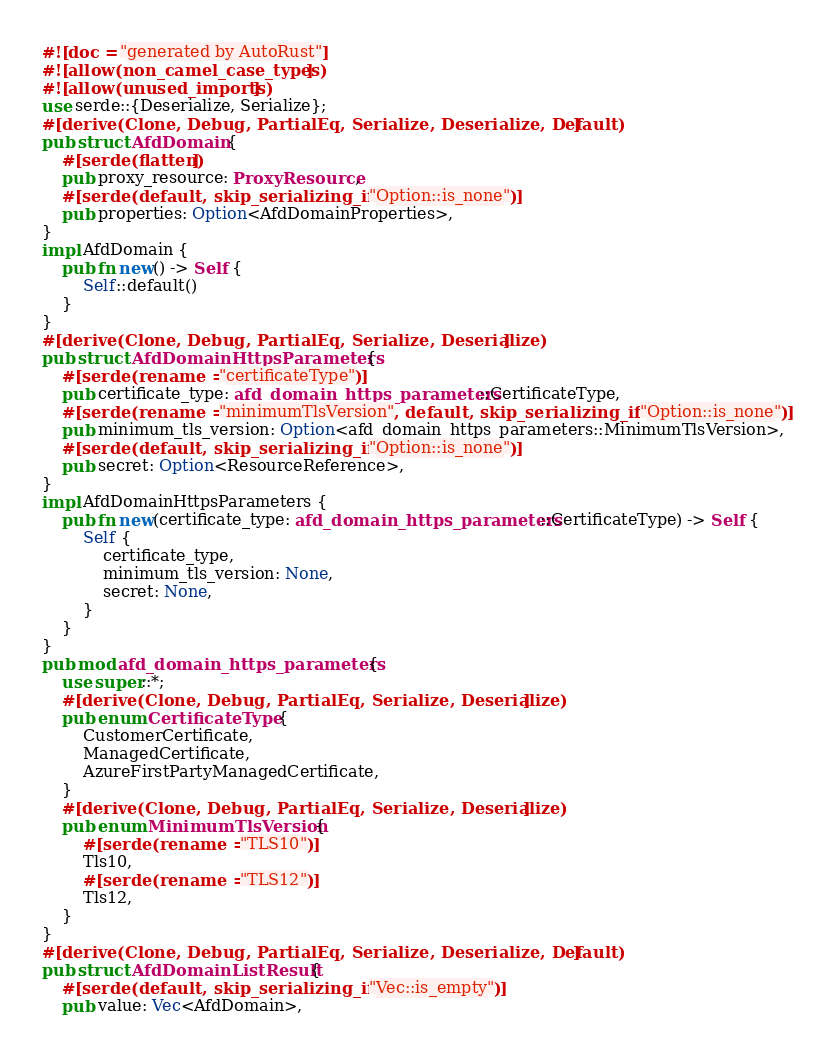<code> <loc_0><loc_0><loc_500><loc_500><_Rust_>#![doc = "generated by AutoRust"]
#![allow(non_camel_case_types)]
#![allow(unused_imports)]
use serde::{Deserialize, Serialize};
#[derive(Clone, Debug, PartialEq, Serialize, Deserialize, Default)]
pub struct AfdDomain {
    #[serde(flatten)]
    pub proxy_resource: ProxyResource,
    #[serde(default, skip_serializing_if = "Option::is_none")]
    pub properties: Option<AfdDomainProperties>,
}
impl AfdDomain {
    pub fn new() -> Self {
        Self::default()
    }
}
#[derive(Clone, Debug, PartialEq, Serialize, Deserialize)]
pub struct AfdDomainHttpsParameters {
    #[serde(rename = "certificateType")]
    pub certificate_type: afd_domain_https_parameters::CertificateType,
    #[serde(rename = "minimumTlsVersion", default, skip_serializing_if = "Option::is_none")]
    pub minimum_tls_version: Option<afd_domain_https_parameters::MinimumTlsVersion>,
    #[serde(default, skip_serializing_if = "Option::is_none")]
    pub secret: Option<ResourceReference>,
}
impl AfdDomainHttpsParameters {
    pub fn new(certificate_type: afd_domain_https_parameters::CertificateType) -> Self {
        Self {
            certificate_type,
            minimum_tls_version: None,
            secret: None,
        }
    }
}
pub mod afd_domain_https_parameters {
    use super::*;
    #[derive(Clone, Debug, PartialEq, Serialize, Deserialize)]
    pub enum CertificateType {
        CustomerCertificate,
        ManagedCertificate,
        AzureFirstPartyManagedCertificate,
    }
    #[derive(Clone, Debug, PartialEq, Serialize, Deserialize)]
    pub enum MinimumTlsVersion {
        #[serde(rename = "TLS10")]
        Tls10,
        #[serde(rename = "TLS12")]
        Tls12,
    }
}
#[derive(Clone, Debug, PartialEq, Serialize, Deserialize, Default)]
pub struct AfdDomainListResult {
    #[serde(default, skip_serializing_if = "Vec::is_empty")]
    pub value: Vec<AfdDomain>,</code> 